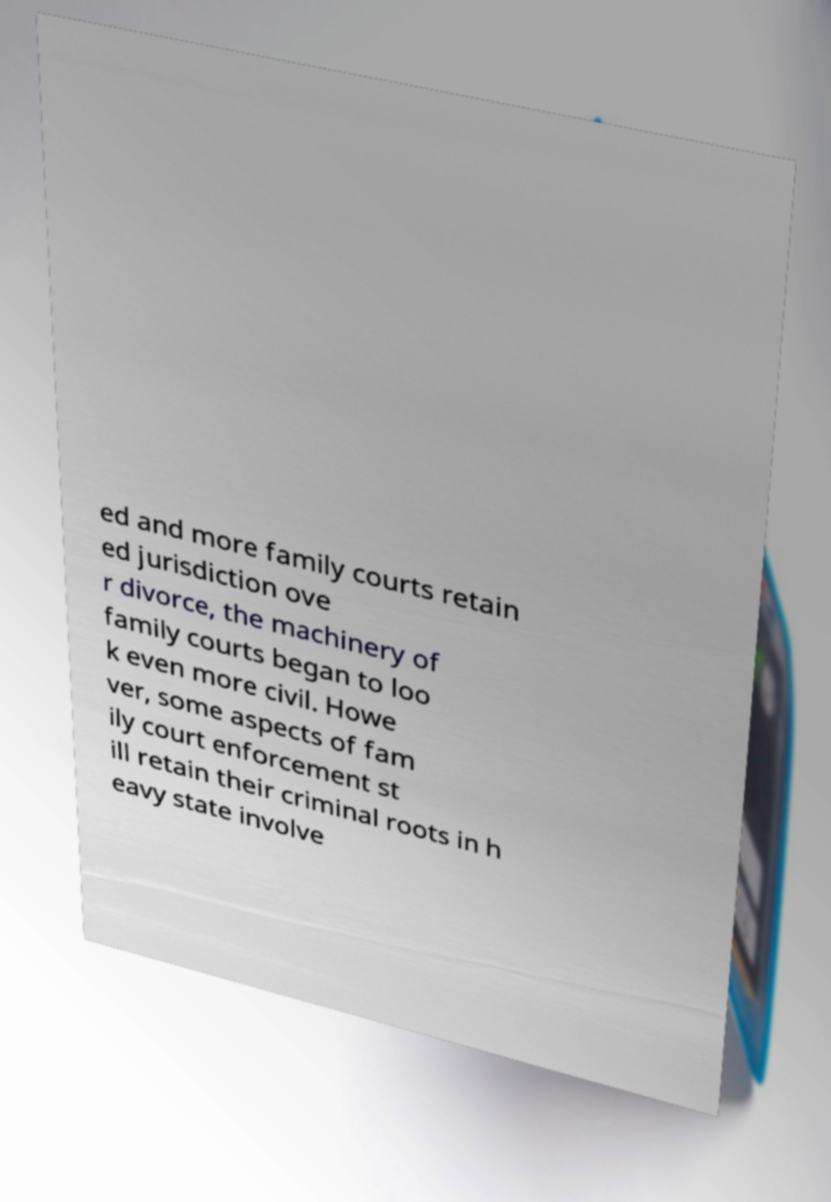Could you extract and type out the text from this image? ed and more family courts retain ed jurisdiction ove r divorce, the machinery of family courts began to loo k even more civil. Howe ver, some aspects of fam ily court enforcement st ill retain their criminal roots in h eavy state involve 